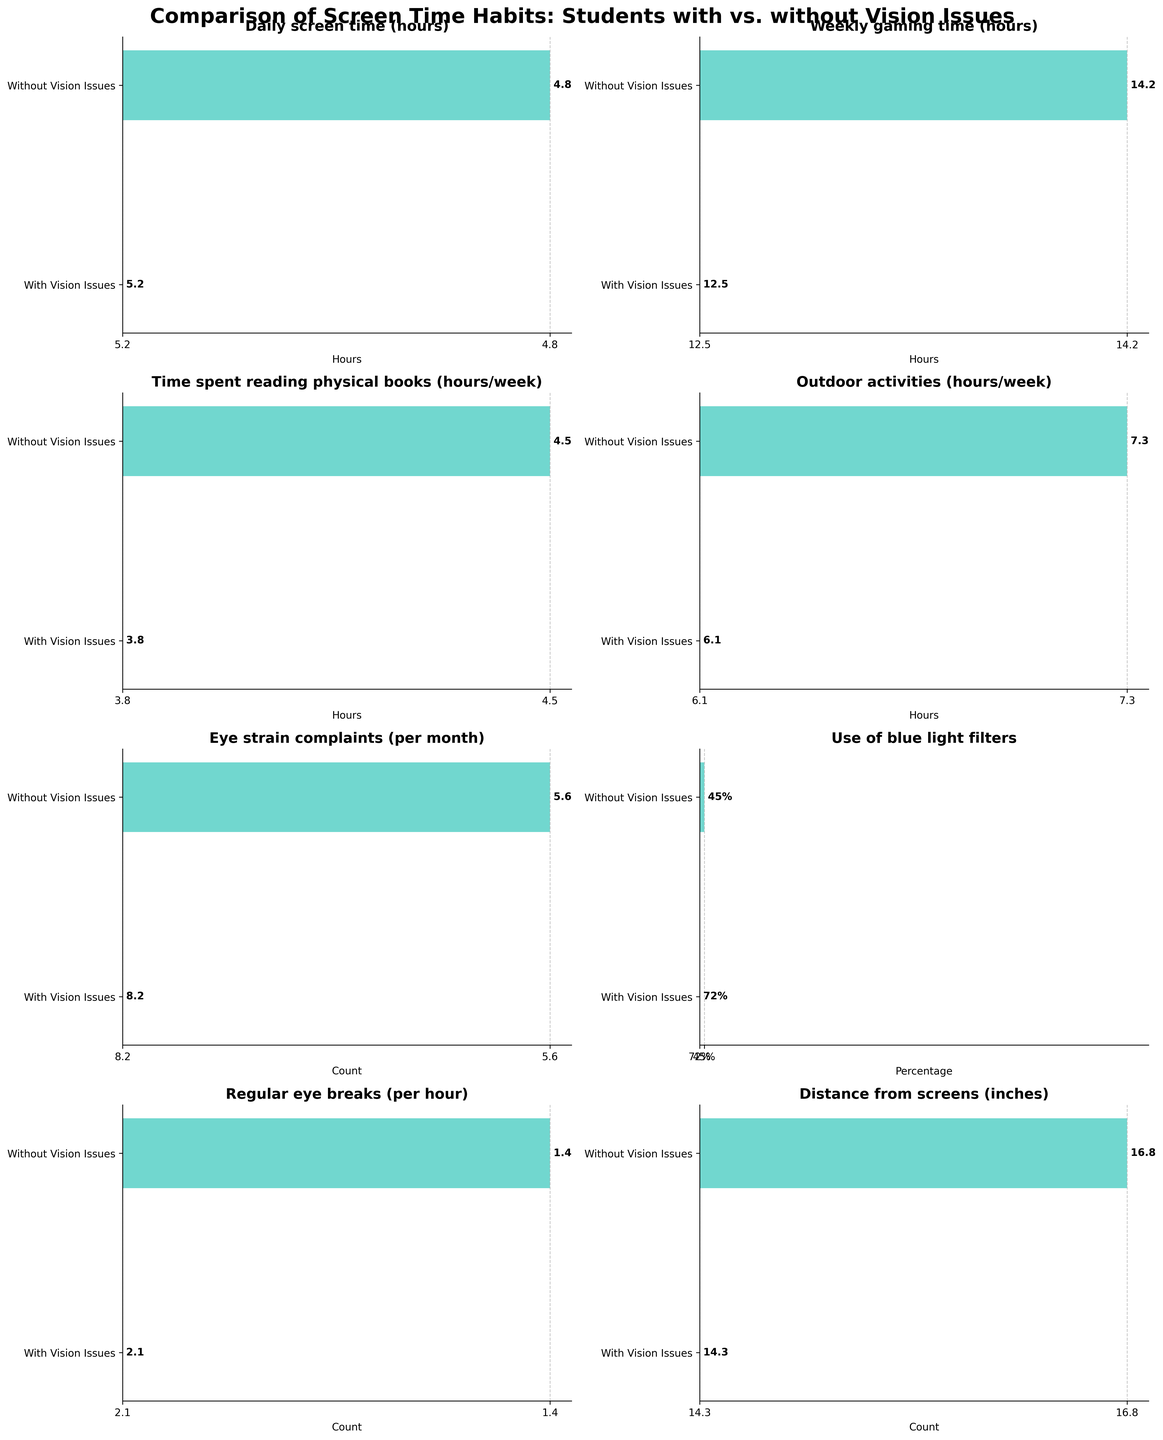How many more hours do students without vision issues spend on weekly gaming time compared to those with vision issues? Students without vision issues spend 14.2 hours on weekly gaming compared to 12.5 hours for those with vision issues. The difference is 14.2 - 12.5 = 1.7 hours.
Answer: 1.7 hours Which group spends more time on outdoor activities? The bar for outdoor activities shows that students without vision issues spend 7.3 hours compared to 6.1 hours for students with vision issues. Thus, students without vision issues spend more time outdoors.
Answer: Students without vision issues What is the percentage difference in the use of blue light filters between the two groups? Students with vision issues use blue light filters at a rate of 72%, while those without use them at 45%. The percentage difference is 72% - 45% = 27%.
Answer: 27% Which category has the smallest difference in values between students with and without vision issues? By examining each subplot, 'Daily screen time (hours)' has the smallest difference (5.2 hours vs. 4.8 hours). The difference is 5.2 - 4.8 = 0.4 hours.
Answer: Daily screen time (hours) What's the sum of outdoor activities and time spent reading physical books for students without vision issues? Students without vision issues spend 7.3 hours on outdoor activities and 4.5 hours on reading physical books. The sum is 7.3 + 4.5 = 11.8 hours.
Answer: 11.8 hours How many more eye strain complaints do students with vision issues have compared to those without? The bar for eye strain complaints shows 8.2 complaints for students with vision issues and 5.6 for those without. The difference is 8.2 - 5.6 = 2.6 complaints.
Answer: 2.6 complaints What is the title of the figure? The figure's title is displayed at the top and reads 'Comparison of Screen Time Habits: Students with vs. without Vision Issues'.
Answer: Comparison of Screen Time Habits: Students with vs. without Vision Issues On average, how many hours per week do students with vision issues spend on reading physical books and outdoor activities combined? Students with vision issues spend 3.8 hours on reading physical books and 6.1 hours on outdoor activities. The average is (3.8 + 6.1) / 2 = 4.95 hours.
Answer: 4.95 hours Which group practices more regular eye breaks per hour? The subplot for 'Regular eye breaks (per hour)' shows students with vision issues take 2.1 breaks compared to 1.4 for those without. Therefore, students with vision issues practice more regular eye breaks.
Answer: Students with vision issues 